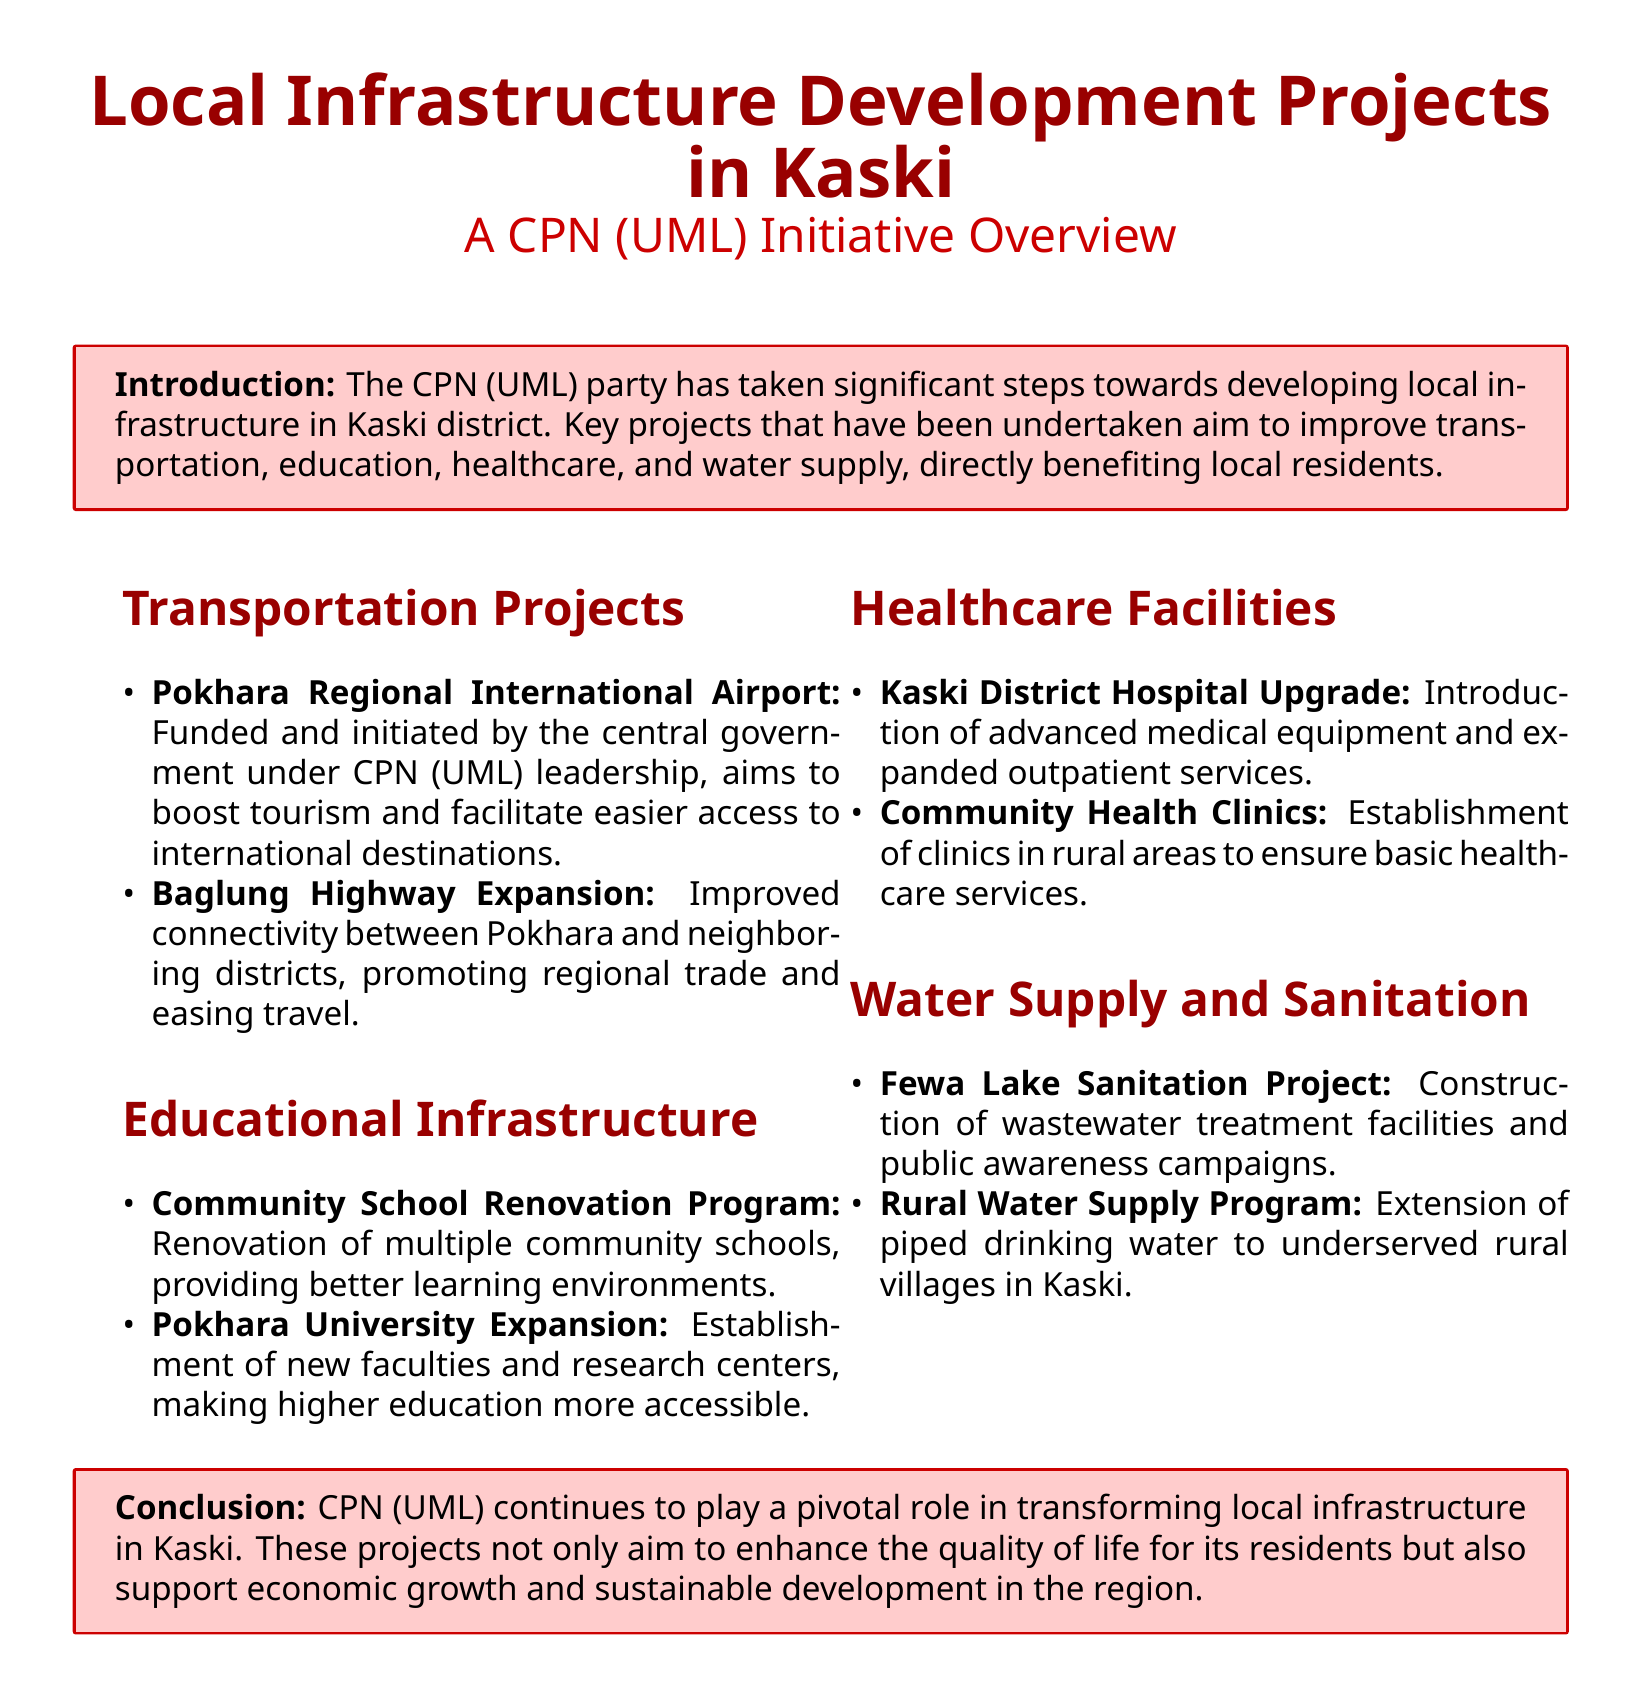What is the main goal of the Local Infrastructure Development Projects in Kaski? The introduction states that the CPN (UML) party aims to improve transportation, education, healthcare, and water supply, directly benefiting local residents.
Answer: Local development What major transportation project is mentioned in the document? The section on Transportation Projects lists the Pokhara Regional International Airport as a significant project.
Answer: Pokhara Regional International Airport Which program focuses on the renovation of schools? The Educational Infrastructure section includes the Community School Renovation Program that focuses on better learning environments.
Answer: Community School Renovation Program What upgrade is planned for healthcare facilities? The Healthcare Facilities section mentions the Kaski District Hospital Upgrade for the introduction of advanced medical equipment.
Answer: Kaski District Hospital Upgrade What is one of the water supply projects mentioned? Under Water Supply and Sanitation, the document highlights the Rural Water Supply Program for extending piped drinking water.
Answer: Rural Water Supply Program How does CPN (UML) contribute to economic development according to the conclusion? The conclusion states that CPN (UML) supports economic growth and sustainable development in the region through its projects.
Answer: Economic growth What new initiative is planned for higher education? In the Educational Infrastructure section, the Pokhara University Expansion mentions establishing new faculties and research centers for accessibility.
Answer: Pokhara University Expansion What role does the CPN (UML) party play in Kaski? The conclusion emphasizes that CPN (UML) plays a pivotal role in transforming local infrastructure as mentioned in the document.
Answer: Pivotal role What type of document is this? The title and structure indicate that the document is a Fact sheet which provides an overview of local projects.
Answer: Fact sheet 